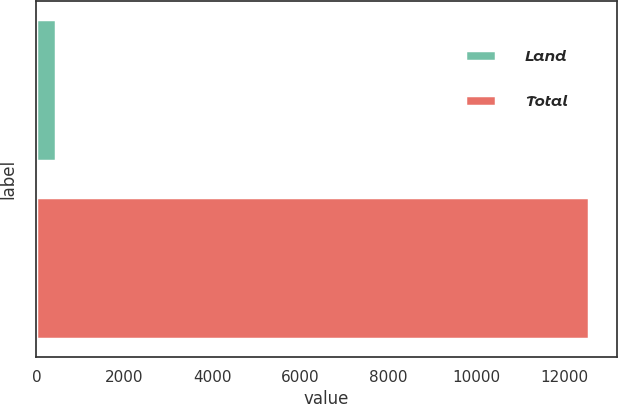Convert chart to OTSL. <chart><loc_0><loc_0><loc_500><loc_500><bar_chart><fcel>Land<fcel>Total<nl><fcel>435<fcel>12546<nl></chart> 